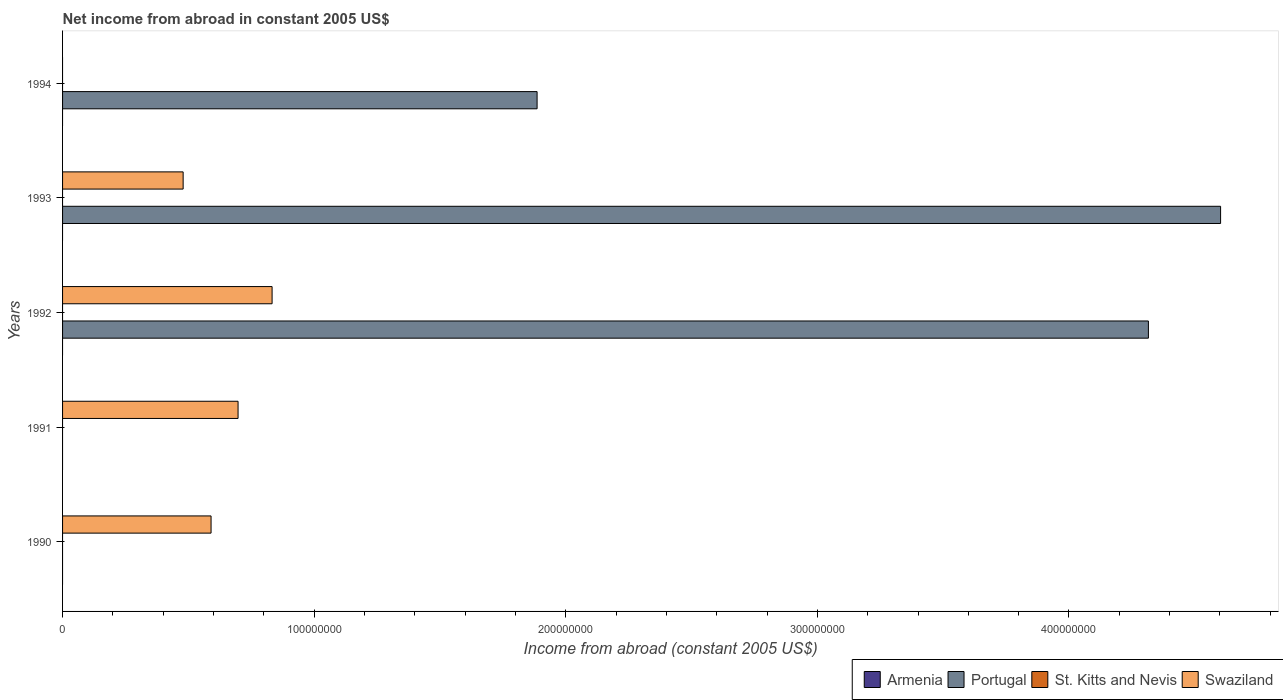Are the number of bars on each tick of the Y-axis equal?
Keep it short and to the point. No. How many bars are there on the 1st tick from the bottom?
Ensure brevity in your answer.  1. What is the net income from abroad in Portugal in 1990?
Keep it short and to the point. 0. Across all years, what is the maximum net income from abroad in Swaziland?
Your answer should be very brief. 8.33e+07. What is the total net income from abroad in Swaziland in the graph?
Give a very brief answer. 2.60e+08. What is the difference between the net income from abroad in Swaziland in 1991 and that in 1992?
Keep it short and to the point. -1.35e+07. What is the difference between the net income from abroad in St. Kitts and Nevis in 1994 and the net income from abroad in Portugal in 1992?
Your answer should be compact. -4.32e+08. What is the average net income from abroad in Armenia per year?
Your response must be concise. 0. In how many years, is the net income from abroad in St. Kitts and Nevis greater than 400000000 US$?
Offer a very short reply. 0. What is the ratio of the net income from abroad in Swaziland in 1990 to that in 1993?
Keep it short and to the point. 1.23. What is the difference between the highest and the second highest net income from abroad in Swaziland?
Offer a terse response. 1.35e+07. What is the difference between the highest and the lowest net income from abroad in Swaziland?
Offer a very short reply. 8.33e+07. In how many years, is the net income from abroad in St. Kitts and Nevis greater than the average net income from abroad in St. Kitts and Nevis taken over all years?
Make the answer very short. 0. Is the sum of the net income from abroad in Swaziland in 1990 and 1992 greater than the maximum net income from abroad in St. Kitts and Nevis across all years?
Your answer should be compact. Yes. What is the difference between two consecutive major ticks on the X-axis?
Provide a short and direct response. 1.00e+08. Does the graph contain grids?
Offer a terse response. No. How are the legend labels stacked?
Offer a terse response. Horizontal. What is the title of the graph?
Offer a very short reply. Net income from abroad in constant 2005 US$. What is the label or title of the X-axis?
Your answer should be compact. Income from abroad (constant 2005 US$). What is the Income from abroad (constant 2005 US$) in St. Kitts and Nevis in 1990?
Your response must be concise. 0. What is the Income from abroad (constant 2005 US$) in Swaziland in 1990?
Give a very brief answer. 5.90e+07. What is the Income from abroad (constant 2005 US$) in Armenia in 1991?
Provide a short and direct response. 0. What is the Income from abroad (constant 2005 US$) of St. Kitts and Nevis in 1991?
Give a very brief answer. 0. What is the Income from abroad (constant 2005 US$) of Swaziland in 1991?
Offer a very short reply. 6.97e+07. What is the Income from abroad (constant 2005 US$) in Portugal in 1992?
Offer a terse response. 4.32e+08. What is the Income from abroad (constant 2005 US$) in St. Kitts and Nevis in 1992?
Offer a terse response. 0. What is the Income from abroad (constant 2005 US$) of Swaziland in 1992?
Give a very brief answer. 8.33e+07. What is the Income from abroad (constant 2005 US$) of Portugal in 1993?
Your answer should be compact. 4.60e+08. What is the Income from abroad (constant 2005 US$) of Swaziland in 1993?
Your answer should be very brief. 4.79e+07. What is the Income from abroad (constant 2005 US$) of Armenia in 1994?
Your answer should be very brief. 0. What is the Income from abroad (constant 2005 US$) in Portugal in 1994?
Provide a short and direct response. 1.89e+08. What is the Income from abroad (constant 2005 US$) in St. Kitts and Nevis in 1994?
Offer a very short reply. 0. Across all years, what is the maximum Income from abroad (constant 2005 US$) of Portugal?
Give a very brief answer. 4.60e+08. Across all years, what is the maximum Income from abroad (constant 2005 US$) in Swaziland?
Provide a short and direct response. 8.33e+07. What is the total Income from abroad (constant 2005 US$) of Portugal in the graph?
Your response must be concise. 1.08e+09. What is the total Income from abroad (constant 2005 US$) in St. Kitts and Nevis in the graph?
Provide a succinct answer. 0. What is the total Income from abroad (constant 2005 US$) of Swaziland in the graph?
Your answer should be compact. 2.60e+08. What is the difference between the Income from abroad (constant 2005 US$) in Swaziland in 1990 and that in 1991?
Provide a short and direct response. -1.07e+07. What is the difference between the Income from abroad (constant 2005 US$) in Swaziland in 1990 and that in 1992?
Make the answer very short. -2.43e+07. What is the difference between the Income from abroad (constant 2005 US$) in Swaziland in 1990 and that in 1993?
Ensure brevity in your answer.  1.11e+07. What is the difference between the Income from abroad (constant 2005 US$) in Swaziland in 1991 and that in 1992?
Provide a short and direct response. -1.35e+07. What is the difference between the Income from abroad (constant 2005 US$) in Swaziland in 1991 and that in 1993?
Your answer should be very brief. 2.18e+07. What is the difference between the Income from abroad (constant 2005 US$) in Portugal in 1992 and that in 1993?
Make the answer very short. -2.87e+07. What is the difference between the Income from abroad (constant 2005 US$) of Swaziland in 1992 and that in 1993?
Your answer should be very brief. 3.54e+07. What is the difference between the Income from abroad (constant 2005 US$) of Portugal in 1992 and that in 1994?
Ensure brevity in your answer.  2.43e+08. What is the difference between the Income from abroad (constant 2005 US$) in Portugal in 1993 and that in 1994?
Offer a terse response. 2.72e+08. What is the difference between the Income from abroad (constant 2005 US$) in Portugal in 1992 and the Income from abroad (constant 2005 US$) in Swaziland in 1993?
Provide a succinct answer. 3.84e+08. What is the average Income from abroad (constant 2005 US$) in Armenia per year?
Ensure brevity in your answer.  0. What is the average Income from abroad (constant 2005 US$) of Portugal per year?
Keep it short and to the point. 2.16e+08. What is the average Income from abroad (constant 2005 US$) in Swaziland per year?
Your answer should be compact. 5.20e+07. In the year 1992, what is the difference between the Income from abroad (constant 2005 US$) of Portugal and Income from abroad (constant 2005 US$) of Swaziland?
Provide a short and direct response. 3.48e+08. In the year 1993, what is the difference between the Income from abroad (constant 2005 US$) of Portugal and Income from abroad (constant 2005 US$) of Swaziland?
Give a very brief answer. 4.12e+08. What is the ratio of the Income from abroad (constant 2005 US$) in Swaziland in 1990 to that in 1991?
Your answer should be very brief. 0.85. What is the ratio of the Income from abroad (constant 2005 US$) of Swaziland in 1990 to that in 1992?
Keep it short and to the point. 0.71. What is the ratio of the Income from abroad (constant 2005 US$) in Swaziland in 1990 to that in 1993?
Offer a very short reply. 1.23. What is the ratio of the Income from abroad (constant 2005 US$) of Swaziland in 1991 to that in 1992?
Your answer should be very brief. 0.84. What is the ratio of the Income from abroad (constant 2005 US$) of Swaziland in 1991 to that in 1993?
Your answer should be very brief. 1.46. What is the ratio of the Income from abroad (constant 2005 US$) of Portugal in 1992 to that in 1993?
Your answer should be very brief. 0.94. What is the ratio of the Income from abroad (constant 2005 US$) of Swaziland in 1992 to that in 1993?
Offer a terse response. 1.74. What is the ratio of the Income from abroad (constant 2005 US$) in Portugal in 1992 to that in 1994?
Your answer should be compact. 2.29. What is the ratio of the Income from abroad (constant 2005 US$) in Portugal in 1993 to that in 1994?
Provide a short and direct response. 2.44. What is the difference between the highest and the second highest Income from abroad (constant 2005 US$) in Portugal?
Make the answer very short. 2.87e+07. What is the difference between the highest and the second highest Income from abroad (constant 2005 US$) in Swaziland?
Ensure brevity in your answer.  1.35e+07. What is the difference between the highest and the lowest Income from abroad (constant 2005 US$) in Portugal?
Give a very brief answer. 4.60e+08. What is the difference between the highest and the lowest Income from abroad (constant 2005 US$) in Swaziland?
Offer a terse response. 8.33e+07. 